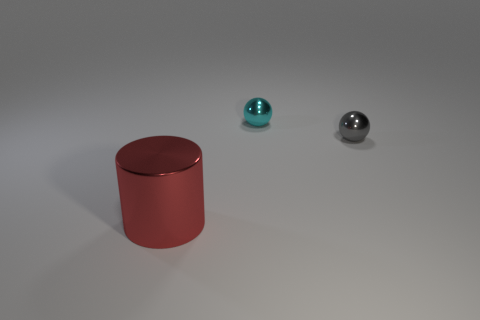Are there any other things that are the same material as the cylinder?
Offer a very short reply. Yes. There is a small metallic thing behind the sphere that is right of the cyan object; are there any tiny cyan objects behind it?
Give a very brief answer. No. There is a big red cylinder that is left of the cyan thing; what material is it?
Provide a succinct answer. Metal. How many small objects are either gray things or cyan shiny spheres?
Offer a very short reply. 2. There is a red metallic cylinder on the left side of the gray sphere; is it the same size as the small gray thing?
Ensure brevity in your answer.  No. How many other objects are the same color as the large cylinder?
Offer a terse response. 0. What is the material of the large thing?
Offer a terse response. Metal. What material is the object that is both behind the big shiny cylinder and to the left of the small gray metallic thing?
Provide a succinct answer. Metal. How many things are balls that are in front of the tiny cyan shiny thing or large red objects?
Provide a short and direct response. 2. Are there any cyan rubber balls of the same size as the red thing?
Provide a short and direct response. No. 